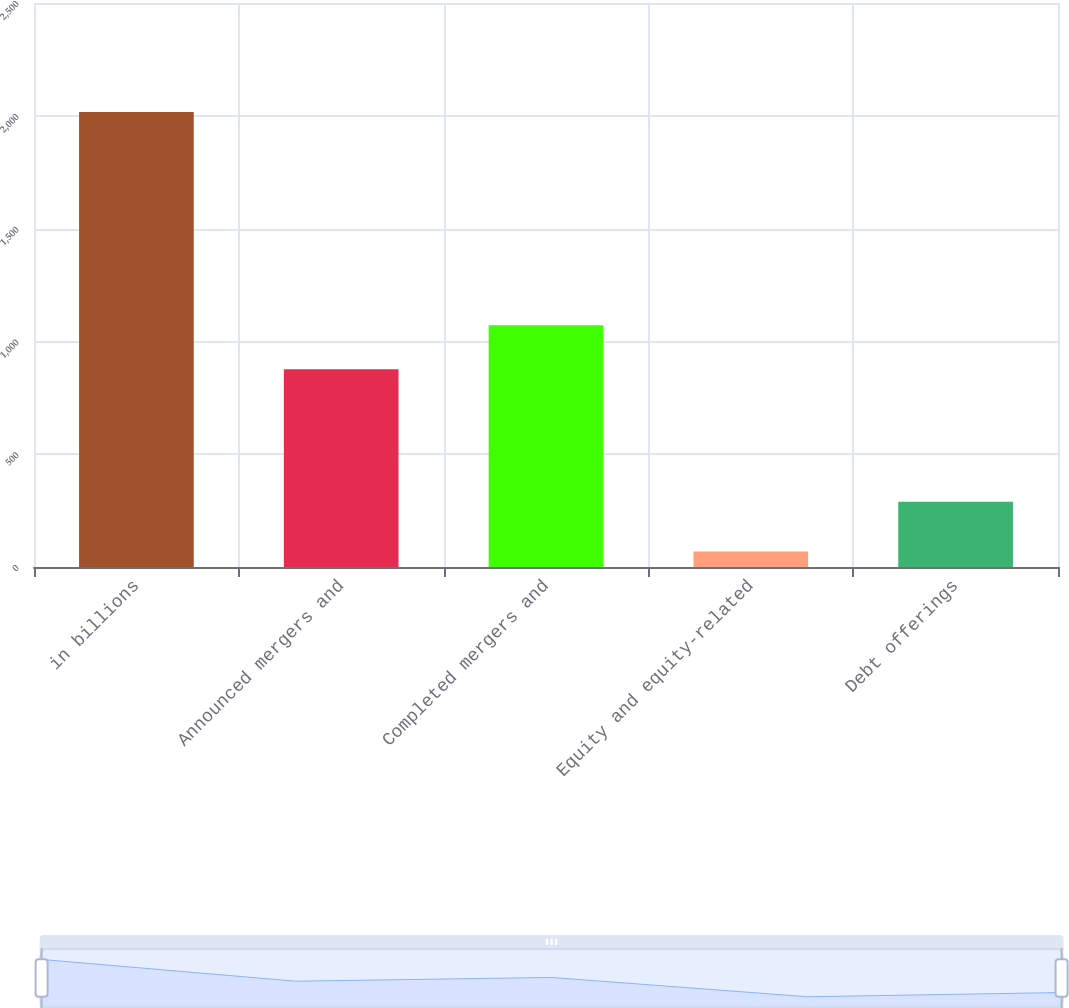<chart> <loc_0><loc_0><loc_500><loc_500><bar_chart><fcel>in billions<fcel>Announced mergers and<fcel>Completed mergers and<fcel>Equity and equity-related<fcel>Debt offerings<nl><fcel>2017<fcel>877<fcel>1071.8<fcel>69<fcel>289<nl></chart> 